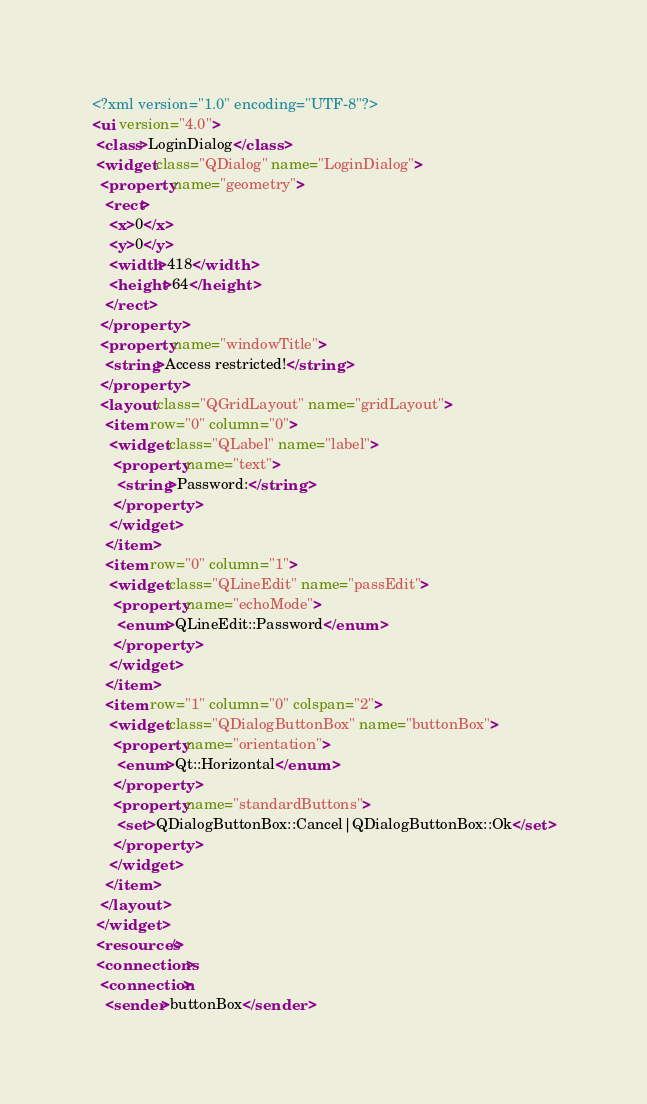Convert code to text. <code><loc_0><loc_0><loc_500><loc_500><_XML_><?xml version="1.0" encoding="UTF-8"?>
<ui version="4.0">
 <class>LoginDialog</class>
 <widget class="QDialog" name="LoginDialog">
  <property name="geometry">
   <rect>
    <x>0</x>
    <y>0</y>
    <width>418</width>
    <height>64</height>
   </rect>
  </property>
  <property name="windowTitle">
   <string>Access restricted!</string>
  </property>
  <layout class="QGridLayout" name="gridLayout">
   <item row="0" column="0">
    <widget class="QLabel" name="label">
     <property name="text">
      <string>Password:</string>
     </property>
    </widget>
   </item>
   <item row="0" column="1">
    <widget class="QLineEdit" name="passEdit">
     <property name="echoMode">
      <enum>QLineEdit::Password</enum>
     </property>
    </widget>
   </item>
   <item row="1" column="0" colspan="2">
    <widget class="QDialogButtonBox" name="buttonBox">
     <property name="orientation">
      <enum>Qt::Horizontal</enum>
     </property>
     <property name="standardButtons">
      <set>QDialogButtonBox::Cancel|QDialogButtonBox::Ok</set>
     </property>
    </widget>
   </item>
  </layout>
 </widget>
 <resources/>
 <connections>
  <connection>
   <sender>buttonBox</sender></code> 